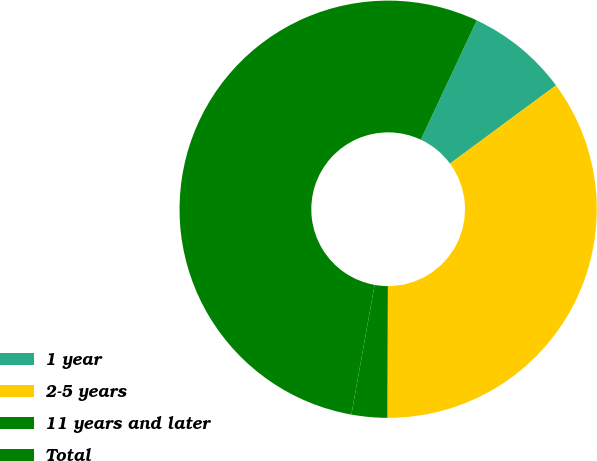<chart> <loc_0><loc_0><loc_500><loc_500><pie_chart><fcel>1 year<fcel>2-5 years<fcel>11 years and later<fcel>Total<nl><fcel>7.9%<fcel>35.18%<fcel>2.76%<fcel>54.17%<nl></chart> 